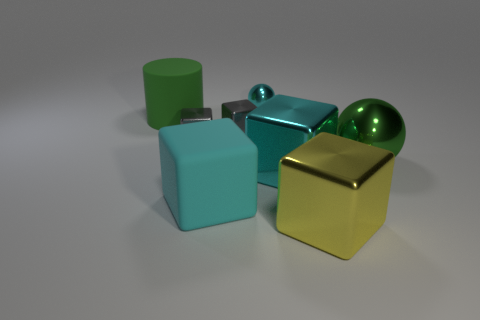Does the large thing on the right side of the big yellow thing have the same shape as the big yellow thing?
Your answer should be very brief. No. Is there any other thing that has the same material as the cyan ball?
Your answer should be very brief. Yes. How many things are small cyan balls or objects to the right of the small cyan shiny sphere?
Your response must be concise. 4. There is a shiny thing that is both behind the cyan shiny cube and on the right side of the small cyan metal object; how big is it?
Make the answer very short. Large. Are there more large green balls on the left side of the yellow metallic thing than gray metallic objects to the right of the big green ball?
Provide a short and direct response. No. Is the shape of the large cyan metallic object the same as the metallic object that is behind the big cylinder?
Ensure brevity in your answer.  No. How many other objects are there of the same shape as the large green shiny object?
Your answer should be very brief. 1. The thing that is in front of the green metal ball and behind the cyan rubber thing is what color?
Make the answer very short. Cyan. What color is the big ball?
Your response must be concise. Green. Does the cylinder have the same material as the small cyan object that is behind the green metal object?
Your answer should be compact. No. 